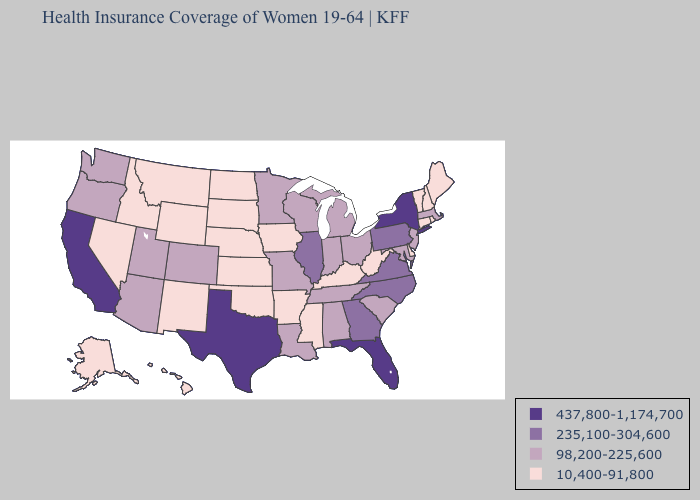Which states hav the highest value in the Northeast?
Be succinct. New York. Does Kansas have the same value as Delaware?
Keep it brief. Yes. Name the states that have a value in the range 437,800-1,174,700?
Keep it brief. California, Florida, New York, Texas. What is the value of New Jersey?
Concise answer only. 98,200-225,600. Among the states that border Arkansas , which have the lowest value?
Concise answer only. Mississippi, Oklahoma. Does Arkansas have the highest value in the South?
Keep it brief. No. Name the states that have a value in the range 98,200-225,600?
Short answer required. Alabama, Arizona, Colorado, Indiana, Louisiana, Maryland, Massachusetts, Michigan, Minnesota, Missouri, New Jersey, Ohio, Oregon, South Carolina, Tennessee, Utah, Washington, Wisconsin. Does the first symbol in the legend represent the smallest category?
Keep it brief. No. Name the states that have a value in the range 235,100-304,600?
Be succinct. Georgia, Illinois, North Carolina, Pennsylvania, Virginia. Does Kansas have the lowest value in the USA?
Be succinct. Yes. Does Kansas have the lowest value in the USA?
Short answer required. Yes. Name the states that have a value in the range 10,400-91,800?
Short answer required. Alaska, Arkansas, Connecticut, Delaware, Hawaii, Idaho, Iowa, Kansas, Kentucky, Maine, Mississippi, Montana, Nebraska, Nevada, New Hampshire, New Mexico, North Dakota, Oklahoma, Rhode Island, South Dakota, Vermont, West Virginia, Wyoming. Which states hav the highest value in the South?
Be succinct. Florida, Texas. Does Illinois have the highest value in the MidWest?
Quick response, please. Yes. Name the states that have a value in the range 235,100-304,600?
Quick response, please. Georgia, Illinois, North Carolina, Pennsylvania, Virginia. 